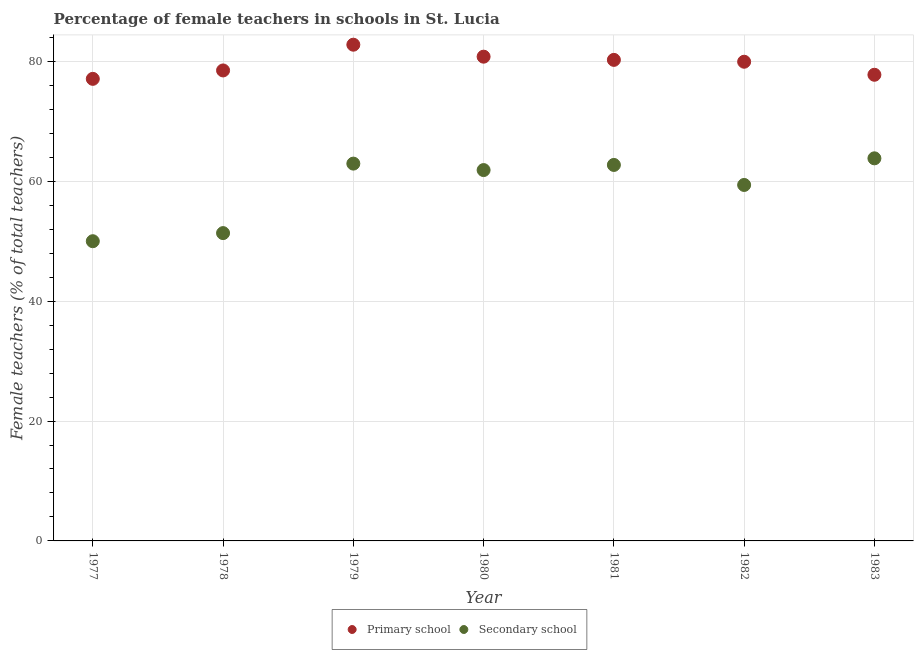How many different coloured dotlines are there?
Your response must be concise. 2. What is the percentage of female teachers in secondary schools in 1980?
Your answer should be compact. 61.87. Across all years, what is the maximum percentage of female teachers in primary schools?
Provide a succinct answer. 82.78. Across all years, what is the minimum percentage of female teachers in secondary schools?
Give a very brief answer. 50. In which year was the percentage of female teachers in primary schools maximum?
Your response must be concise. 1979. In which year was the percentage of female teachers in primary schools minimum?
Your answer should be very brief. 1977. What is the total percentage of female teachers in secondary schools in the graph?
Make the answer very short. 412.1. What is the difference between the percentage of female teachers in primary schools in 1981 and that in 1982?
Offer a very short reply. 0.31. What is the difference between the percentage of female teachers in primary schools in 1981 and the percentage of female teachers in secondary schools in 1983?
Provide a short and direct response. 16.42. What is the average percentage of female teachers in primary schools per year?
Your answer should be very brief. 79.59. In the year 1980, what is the difference between the percentage of female teachers in primary schools and percentage of female teachers in secondary schools?
Keep it short and to the point. 18.92. In how many years, is the percentage of female teachers in secondary schools greater than 12 %?
Your response must be concise. 7. What is the ratio of the percentage of female teachers in primary schools in 1978 to that in 1982?
Offer a very short reply. 0.98. What is the difference between the highest and the second highest percentage of female teachers in secondary schools?
Keep it short and to the point. 0.88. What is the difference between the highest and the lowest percentage of female teachers in primary schools?
Give a very brief answer. 5.7. In how many years, is the percentage of female teachers in primary schools greater than the average percentage of female teachers in primary schools taken over all years?
Your answer should be compact. 4. Does the percentage of female teachers in primary schools monotonically increase over the years?
Give a very brief answer. No. Is the percentage of female teachers in primary schools strictly greater than the percentage of female teachers in secondary schools over the years?
Ensure brevity in your answer.  Yes. How many years are there in the graph?
Your response must be concise. 7. Are the values on the major ticks of Y-axis written in scientific E-notation?
Provide a short and direct response. No. How many legend labels are there?
Your response must be concise. 2. How are the legend labels stacked?
Your answer should be very brief. Horizontal. What is the title of the graph?
Keep it short and to the point. Percentage of female teachers in schools in St. Lucia. Does "Female entrants" appear as one of the legend labels in the graph?
Your response must be concise. No. What is the label or title of the X-axis?
Provide a succinct answer. Year. What is the label or title of the Y-axis?
Give a very brief answer. Female teachers (% of total teachers). What is the Female teachers (% of total teachers) in Primary school in 1977?
Offer a very short reply. 77.09. What is the Female teachers (% of total teachers) of Primary school in 1978?
Your answer should be very brief. 78.49. What is the Female teachers (% of total teachers) of Secondary school in 1978?
Your answer should be compact. 51.35. What is the Female teachers (% of total teachers) in Primary school in 1979?
Give a very brief answer. 82.78. What is the Female teachers (% of total teachers) in Secondary school in 1979?
Provide a short and direct response. 62.95. What is the Female teachers (% of total teachers) in Primary school in 1980?
Provide a short and direct response. 80.79. What is the Female teachers (% of total teachers) in Secondary school in 1980?
Offer a terse response. 61.87. What is the Female teachers (% of total teachers) of Primary school in 1981?
Your answer should be very brief. 80.25. What is the Female teachers (% of total teachers) in Secondary school in 1981?
Keep it short and to the point. 62.72. What is the Female teachers (% of total teachers) of Primary school in 1982?
Ensure brevity in your answer.  79.94. What is the Female teachers (% of total teachers) of Secondary school in 1982?
Keep it short and to the point. 59.38. What is the Female teachers (% of total teachers) of Primary school in 1983?
Make the answer very short. 77.77. What is the Female teachers (% of total teachers) in Secondary school in 1983?
Offer a terse response. 63.83. Across all years, what is the maximum Female teachers (% of total teachers) in Primary school?
Give a very brief answer. 82.78. Across all years, what is the maximum Female teachers (% of total teachers) in Secondary school?
Provide a short and direct response. 63.83. Across all years, what is the minimum Female teachers (% of total teachers) of Primary school?
Offer a very short reply. 77.09. What is the total Female teachers (% of total teachers) in Primary school in the graph?
Your answer should be compact. 557.1. What is the total Female teachers (% of total teachers) in Secondary school in the graph?
Give a very brief answer. 412.1. What is the difference between the Female teachers (% of total teachers) of Primary school in 1977 and that in 1978?
Your response must be concise. -1.4. What is the difference between the Female teachers (% of total teachers) in Secondary school in 1977 and that in 1978?
Keep it short and to the point. -1.35. What is the difference between the Female teachers (% of total teachers) in Primary school in 1977 and that in 1979?
Your response must be concise. -5.7. What is the difference between the Female teachers (% of total teachers) in Secondary school in 1977 and that in 1979?
Give a very brief answer. -12.95. What is the difference between the Female teachers (% of total teachers) of Secondary school in 1977 and that in 1980?
Give a very brief answer. -11.87. What is the difference between the Female teachers (% of total teachers) in Primary school in 1977 and that in 1981?
Your response must be concise. -3.17. What is the difference between the Female teachers (% of total teachers) in Secondary school in 1977 and that in 1981?
Your answer should be very brief. -12.72. What is the difference between the Female teachers (% of total teachers) in Primary school in 1977 and that in 1982?
Your answer should be compact. -2.86. What is the difference between the Female teachers (% of total teachers) in Secondary school in 1977 and that in 1982?
Keep it short and to the point. -9.38. What is the difference between the Female teachers (% of total teachers) of Primary school in 1977 and that in 1983?
Offer a very short reply. -0.68. What is the difference between the Female teachers (% of total teachers) in Secondary school in 1977 and that in 1983?
Make the answer very short. -13.83. What is the difference between the Female teachers (% of total teachers) in Primary school in 1978 and that in 1979?
Give a very brief answer. -4.29. What is the difference between the Female teachers (% of total teachers) in Secondary school in 1978 and that in 1979?
Your answer should be very brief. -11.59. What is the difference between the Female teachers (% of total teachers) of Primary school in 1978 and that in 1980?
Your answer should be compact. -2.3. What is the difference between the Female teachers (% of total teachers) of Secondary school in 1978 and that in 1980?
Give a very brief answer. -10.52. What is the difference between the Female teachers (% of total teachers) of Primary school in 1978 and that in 1981?
Provide a succinct answer. -1.76. What is the difference between the Female teachers (% of total teachers) of Secondary school in 1978 and that in 1981?
Your answer should be very brief. -11.37. What is the difference between the Female teachers (% of total teachers) in Primary school in 1978 and that in 1982?
Ensure brevity in your answer.  -1.45. What is the difference between the Female teachers (% of total teachers) of Secondary school in 1978 and that in 1982?
Offer a very short reply. -8.03. What is the difference between the Female teachers (% of total teachers) in Primary school in 1978 and that in 1983?
Keep it short and to the point. 0.72. What is the difference between the Female teachers (% of total teachers) in Secondary school in 1978 and that in 1983?
Offer a terse response. -12.48. What is the difference between the Female teachers (% of total teachers) of Primary school in 1979 and that in 1980?
Your answer should be compact. 2. What is the difference between the Female teachers (% of total teachers) of Secondary school in 1979 and that in 1980?
Offer a very short reply. 1.08. What is the difference between the Female teachers (% of total teachers) in Primary school in 1979 and that in 1981?
Your response must be concise. 2.53. What is the difference between the Female teachers (% of total teachers) in Secondary school in 1979 and that in 1981?
Offer a terse response. 0.22. What is the difference between the Female teachers (% of total teachers) of Primary school in 1979 and that in 1982?
Offer a terse response. 2.84. What is the difference between the Female teachers (% of total teachers) of Secondary school in 1979 and that in 1982?
Ensure brevity in your answer.  3.56. What is the difference between the Female teachers (% of total teachers) in Primary school in 1979 and that in 1983?
Offer a very short reply. 5.02. What is the difference between the Female teachers (% of total teachers) in Secondary school in 1979 and that in 1983?
Provide a short and direct response. -0.88. What is the difference between the Female teachers (% of total teachers) in Primary school in 1980 and that in 1981?
Offer a very short reply. 0.53. What is the difference between the Female teachers (% of total teachers) of Secondary school in 1980 and that in 1981?
Offer a very short reply. -0.86. What is the difference between the Female teachers (% of total teachers) in Primary school in 1980 and that in 1982?
Offer a terse response. 0.84. What is the difference between the Female teachers (% of total teachers) in Secondary school in 1980 and that in 1982?
Your answer should be very brief. 2.48. What is the difference between the Female teachers (% of total teachers) in Primary school in 1980 and that in 1983?
Make the answer very short. 3.02. What is the difference between the Female teachers (% of total teachers) of Secondary school in 1980 and that in 1983?
Give a very brief answer. -1.96. What is the difference between the Female teachers (% of total teachers) of Primary school in 1981 and that in 1982?
Provide a short and direct response. 0.31. What is the difference between the Female teachers (% of total teachers) of Secondary school in 1981 and that in 1982?
Offer a terse response. 3.34. What is the difference between the Female teachers (% of total teachers) of Primary school in 1981 and that in 1983?
Ensure brevity in your answer.  2.48. What is the difference between the Female teachers (% of total teachers) in Secondary school in 1981 and that in 1983?
Provide a succinct answer. -1.1. What is the difference between the Female teachers (% of total teachers) in Primary school in 1982 and that in 1983?
Ensure brevity in your answer.  2.17. What is the difference between the Female teachers (% of total teachers) in Secondary school in 1982 and that in 1983?
Provide a succinct answer. -4.44. What is the difference between the Female teachers (% of total teachers) in Primary school in 1977 and the Female teachers (% of total teachers) in Secondary school in 1978?
Offer a very short reply. 25.73. What is the difference between the Female teachers (% of total teachers) in Primary school in 1977 and the Female teachers (% of total teachers) in Secondary school in 1979?
Offer a terse response. 14.14. What is the difference between the Female teachers (% of total teachers) in Primary school in 1977 and the Female teachers (% of total teachers) in Secondary school in 1980?
Provide a succinct answer. 15.22. What is the difference between the Female teachers (% of total teachers) of Primary school in 1977 and the Female teachers (% of total teachers) of Secondary school in 1981?
Give a very brief answer. 14.36. What is the difference between the Female teachers (% of total teachers) of Primary school in 1977 and the Female teachers (% of total teachers) of Secondary school in 1982?
Keep it short and to the point. 17.7. What is the difference between the Female teachers (% of total teachers) in Primary school in 1977 and the Female teachers (% of total teachers) in Secondary school in 1983?
Keep it short and to the point. 13.26. What is the difference between the Female teachers (% of total teachers) of Primary school in 1978 and the Female teachers (% of total teachers) of Secondary school in 1979?
Your response must be concise. 15.54. What is the difference between the Female teachers (% of total teachers) in Primary school in 1978 and the Female teachers (% of total teachers) in Secondary school in 1980?
Keep it short and to the point. 16.62. What is the difference between the Female teachers (% of total teachers) of Primary school in 1978 and the Female teachers (% of total teachers) of Secondary school in 1981?
Provide a succinct answer. 15.77. What is the difference between the Female teachers (% of total teachers) of Primary school in 1978 and the Female teachers (% of total teachers) of Secondary school in 1982?
Your answer should be compact. 19.1. What is the difference between the Female teachers (% of total teachers) of Primary school in 1978 and the Female teachers (% of total teachers) of Secondary school in 1983?
Make the answer very short. 14.66. What is the difference between the Female teachers (% of total teachers) of Primary school in 1979 and the Female teachers (% of total teachers) of Secondary school in 1980?
Give a very brief answer. 20.92. What is the difference between the Female teachers (% of total teachers) in Primary school in 1979 and the Female teachers (% of total teachers) in Secondary school in 1981?
Offer a very short reply. 20.06. What is the difference between the Female teachers (% of total teachers) of Primary school in 1979 and the Female teachers (% of total teachers) of Secondary school in 1982?
Your response must be concise. 23.4. What is the difference between the Female teachers (% of total teachers) in Primary school in 1979 and the Female teachers (% of total teachers) in Secondary school in 1983?
Provide a short and direct response. 18.96. What is the difference between the Female teachers (% of total teachers) in Primary school in 1980 and the Female teachers (% of total teachers) in Secondary school in 1981?
Provide a short and direct response. 18.06. What is the difference between the Female teachers (% of total teachers) of Primary school in 1980 and the Female teachers (% of total teachers) of Secondary school in 1982?
Your response must be concise. 21.4. What is the difference between the Female teachers (% of total teachers) of Primary school in 1980 and the Female teachers (% of total teachers) of Secondary school in 1983?
Your answer should be compact. 16.96. What is the difference between the Female teachers (% of total teachers) of Primary school in 1981 and the Female teachers (% of total teachers) of Secondary school in 1982?
Your response must be concise. 20.87. What is the difference between the Female teachers (% of total teachers) in Primary school in 1981 and the Female teachers (% of total teachers) in Secondary school in 1983?
Provide a short and direct response. 16.42. What is the difference between the Female teachers (% of total teachers) in Primary school in 1982 and the Female teachers (% of total teachers) in Secondary school in 1983?
Make the answer very short. 16.11. What is the average Female teachers (% of total teachers) in Primary school per year?
Provide a short and direct response. 79.59. What is the average Female teachers (% of total teachers) of Secondary school per year?
Offer a very short reply. 58.87. In the year 1977, what is the difference between the Female teachers (% of total teachers) in Primary school and Female teachers (% of total teachers) in Secondary school?
Provide a short and direct response. 27.09. In the year 1978, what is the difference between the Female teachers (% of total teachers) in Primary school and Female teachers (% of total teachers) in Secondary school?
Your answer should be very brief. 27.14. In the year 1979, what is the difference between the Female teachers (% of total teachers) in Primary school and Female teachers (% of total teachers) in Secondary school?
Provide a short and direct response. 19.84. In the year 1980, what is the difference between the Female teachers (% of total teachers) of Primary school and Female teachers (% of total teachers) of Secondary school?
Ensure brevity in your answer.  18.92. In the year 1981, what is the difference between the Female teachers (% of total teachers) of Primary school and Female teachers (% of total teachers) of Secondary school?
Offer a very short reply. 17.53. In the year 1982, what is the difference between the Female teachers (% of total teachers) in Primary school and Female teachers (% of total teachers) in Secondary school?
Offer a terse response. 20.56. In the year 1983, what is the difference between the Female teachers (% of total teachers) in Primary school and Female teachers (% of total teachers) in Secondary school?
Your response must be concise. 13.94. What is the ratio of the Female teachers (% of total teachers) in Primary school in 1977 to that in 1978?
Provide a short and direct response. 0.98. What is the ratio of the Female teachers (% of total teachers) of Secondary school in 1977 to that in 1978?
Your answer should be compact. 0.97. What is the ratio of the Female teachers (% of total teachers) in Primary school in 1977 to that in 1979?
Provide a succinct answer. 0.93. What is the ratio of the Female teachers (% of total teachers) in Secondary school in 1977 to that in 1979?
Provide a succinct answer. 0.79. What is the ratio of the Female teachers (% of total teachers) of Primary school in 1977 to that in 1980?
Give a very brief answer. 0.95. What is the ratio of the Female teachers (% of total teachers) in Secondary school in 1977 to that in 1980?
Provide a succinct answer. 0.81. What is the ratio of the Female teachers (% of total teachers) in Primary school in 1977 to that in 1981?
Your response must be concise. 0.96. What is the ratio of the Female teachers (% of total teachers) of Secondary school in 1977 to that in 1981?
Make the answer very short. 0.8. What is the ratio of the Female teachers (% of total teachers) in Primary school in 1977 to that in 1982?
Your response must be concise. 0.96. What is the ratio of the Female teachers (% of total teachers) of Secondary school in 1977 to that in 1982?
Make the answer very short. 0.84. What is the ratio of the Female teachers (% of total teachers) of Secondary school in 1977 to that in 1983?
Ensure brevity in your answer.  0.78. What is the ratio of the Female teachers (% of total teachers) of Primary school in 1978 to that in 1979?
Provide a short and direct response. 0.95. What is the ratio of the Female teachers (% of total teachers) in Secondary school in 1978 to that in 1979?
Make the answer very short. 0.82. What is the ratio of the Female teachers (% of total teachers) of Primary school in 1978 to that in 1980?
Offer a very short reply. 0.97. What is the ratio of the Female teachers (% of total teachers) of Secondary school in 1978 to that in 1980?
Give a very brief answer. 0.83. What is the ratio of the Female teachers (% of total teachers) in Secondary school in 1978 to that in 1981?
Offer a terse response. 0.82. What is the ratio of the Female teachers (% of total teachers) in Primary school in 1978 to that in 1982?
Provide a succinct answer. 0.98. What is the ratio of the Female teachers (% of total teachers) of Secondary school in 1978 to that in 1982?
Ensure brevity in your answer.  0.86. What is the ratio of the Female teachers (% of total teachers) of Primary school in 1978 to that in 1983?
Provide a succinct answer. 1.01. What is the ratio of the Female teachers (% of total teachers) in Secondary school in 1978 to that in 1983?
Offer a very short reply. 0.8. What is the ratio of the Female teachers (% of total teachers) of Primary school in 1979 to that in 1980?
Ensure brevity in your answer.  1.02. What is the ratio of the Female teachers (% of total teachers) in Secondary school in 1979 to that in 1980?
Your answer should be very brief. 1.02. What is the ratio of the Female teachers (% of total teachers) in Primary school in 1979 to that in 1981?
Provide a short and direct response. 1.03. What is the ratio of the Female teachers (% of total teachers) in Primary school in 1979 to that in 1982?
Your answer should be very brief. 1.04. What is the ratio of the Female teachers (% of total teachers) of Secondary school in 1979 to that in 1982?
Ensure brevity in your answer.  1.06. What is the ratio of the Female teachers (% of total teachers) in Primary school in 1979 to that in 1983?
Provide a short and direct response. 1.06. What is the ratio of the Female teachers (% of total teachers) in Secondary school in 1979 to that in 1983?
Offer a terse response. 0.99. What is the ratio of the Female teachers (% of total teachers) of Primary school in 1980 to that in 1981?
Make the answer very short. 1.01. What is the ratio of the Female teachers (% of total teachers) in Secondary school in 1980 to that in 1981?
Ensure brevity in your answer.  0.99. What is the ratio of the Female teachers (% of total teachers) of Primary school in 1980 to that in 1982?
Make the answer very short. 1.01. What is the ratio of the Female teachers (% of total teachers) in Secondary school in 1980 to that in 1982?
Provide a succinct answer. 1.04. What is the ratio of the Female teachers (% of total teachers) of Primary school in 1980 to that in 1983?
Offer a terse response. 1.04. What is the ratio of the Female teachers (% of total teachers) of Secondary school in 1980 to that in 1983?
Provide a short and direct response. 0.97. What is the ratio of the Female teachers (% of total teachers) in Primary school in 1981 to that in 1982?
Make the answer very short. 1. What is the ratio of the Female teachers (% of total teachers) of Secondary school in 1981 to that in 1982?
Your answer should be compact. 1.06. What is the ratio of the Female teachers (% of total teachers) in Primary school in 1981 to that in 1983?
Provide a short and direct response. 1.03. What is the ratio of the Female teachers (% of total teachers) of Secondary school in 1981 to that in 1983?
Provide a short and direct response. 0.98. What is the ratio of the Female teachers (% of total teachers) in Primary school in 1982 to that in 1983?
Provide a succinct answer. 1.03. What is the ratio of the Female teachers (% of total teachers) of Secondary school in 1982 to that in 1983?
Provide a succinct answer. 0.93. What is the difference between the highest and the second highest Female teachers (% of total teachers) in Primary school?
Offer a very short reply. 2. What is the difference between the highest and the second highest Female teachers (% of total teachers) of Secondary school?
Make the answer very short. 0.88. What is the difference between the highest and the lowest Female teachers (% of total teachers) of Primary school?
Offer a terse response. 5.7. What is the difference between the highest and the lowest Female teachers (% of total teachers) of Secondary school?
Your response must be concise. 13.83. 